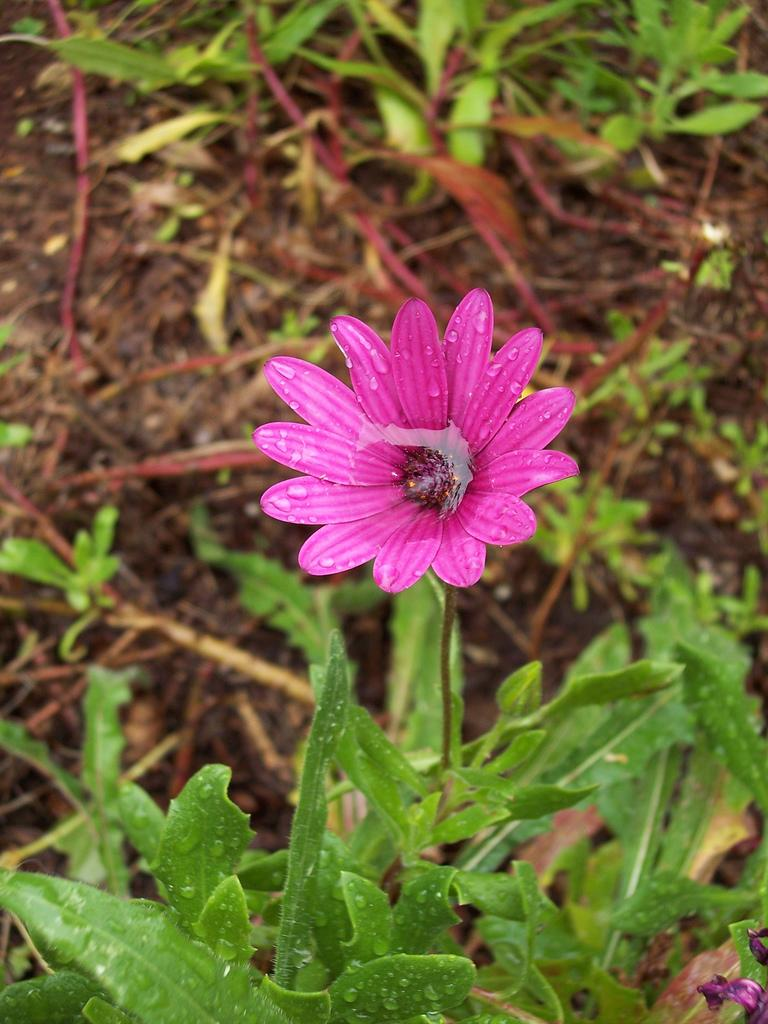What is the main subject of the image? The main subject of the image is a flower with water drops. Are there any other plants visible in the image? Yes, there are plants on the ground in the image. Where are the books stored in the image? There are no books present in the image. Is there a prison visible in the image? There is no prison present in the image. 